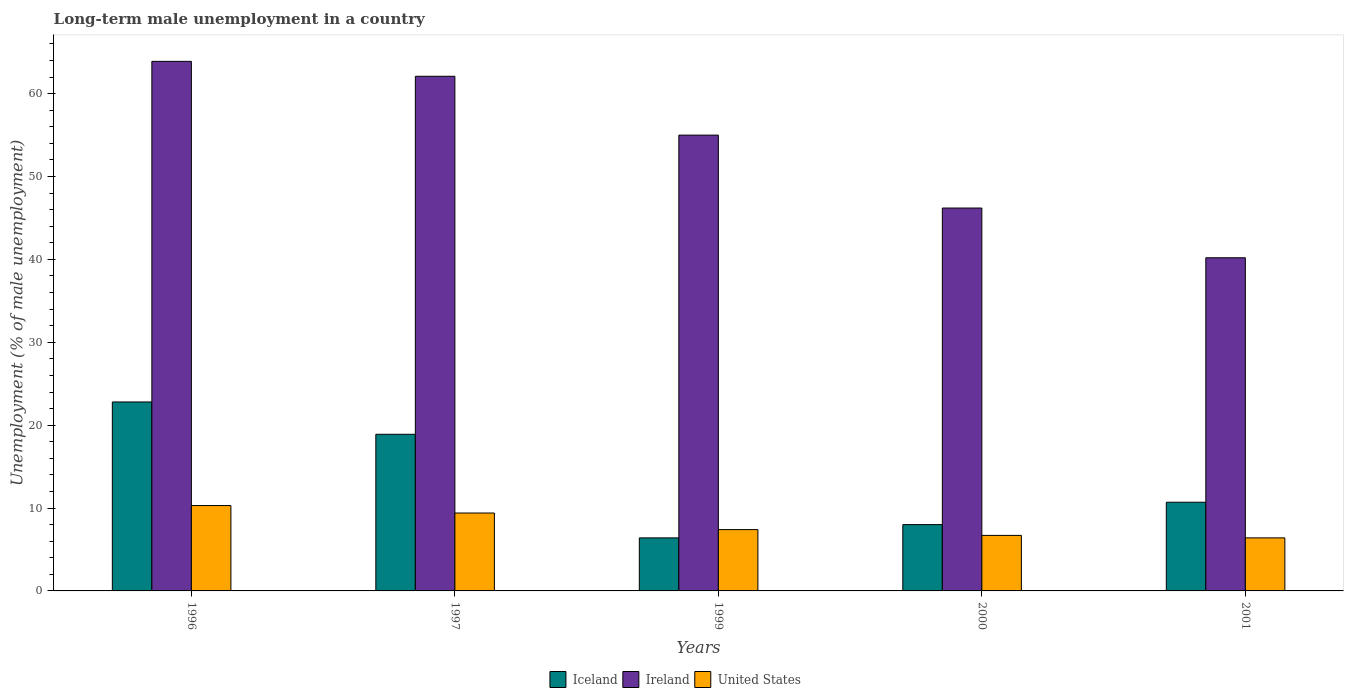Are the number of bars on each tick of the X-axis equal?
Your answer should be compact. Yes. How many bars are there on the 3rd tick from the left?
Provide a succinct answer. 3. How many bars are there on the 3rd tick from the right?
Your response must be concise. 3. What is the label of the 5th group of bars from the left?
Offer a terse response. 2001. What is the percentage of long-term unemployed male population in Ireland in 1997?
Provide a succinct answer. 62.1. Across all years, what is the maximum percentage of long-term unemployed male population in United States?
Provide a short and direct response. 10.3. Across all years, what is the minimum percentage of long-term unemployed male population in United States?
Make the answer very short. 6.4. What is the total percentage of long-term unemployed male population in Iceland in the graph?
Keep it short and to the point. 66.8. What is the difference between the percentage of long-term unemployed male population in United States in 1996 and that in 2001?
Offer a very short reply. 3.9. What is the difference between the percentage of long-term unemployed male population in Iceland in 2001 and the percentage of long-term unemployed male population in United States in 1996?
Provide a short and direct response. 0.4. What is the average percentage of long-term unemployed male population in Iceland per year?
Provide a succinct answer. 13.36. In the year 1996, what is the difference between the percentage of long-term unemployed male population in Ireland and percentage of long-term unemployed male population in Iceland?
Give a very brief answer. 41.1. In how many years, is the percentage of long-term unemployed male population in United States greater than 2 %?
Your answer should be very brief. 5. What is the ratio of the percentage of long-term unemployed male population in Ireland in 1997 to that in 1999?
Offer a terse response. 1.13. Is the difference between the percentage of long-term unemployed male population in Ireland in 1996 and 1999 greater than the difference between the percentage of long-term unemployed male population in Iceland in 1996 and 1999?
Your answer should be compact. No. What is the difference between the highest and the second highest percentage of long-term unemployed male population in United States?
Provide a short and direct response. 0.9. What is the difference between the highest and the lowest percentage of long-term unemployed male population in Iceland?
Your answer should be compact. 16.4. In how many years, is the percentage of long-term unemployed male population in Ireland greater than the average percentage of long-term unemployed male population in Ireland taken over all years?
Your answer should be compact. 3. What does the 1st bar from the left in 1999 represents?
Offer a very short reply. Iceland. What does the 3rd bar from the right in 1997 represents?
Give a very brief answer. Iceland. Is it the case that in every year, the sum of the percentage of long-term unemployed male population in United States and percentage of long-term unemployed male population in Ireland is greater than the percentage of long-term unemployed male population in Iceland?
Your answer should be compact. Yes. Are all the bars in the graph horizontal?
Offer a terse response. No. How many years are there in the graph?
Keep it short and to the point. 5. Does the graph contain any zero values?
Ensure brevity in your answer.  No. Does the graph contain grids?
Provide a succinct answer. No. Where does the legend appear in the graph?
Keep it short and to the point. Bottom center. What is the title of the graph?
Provide a succinct answer. Long-term male unemployment in a country. What is the label or title of the Y-axis?
Your answer should be compact. Unemployment (% of male unemployment). What is the Unemployment (% of male unemployment) in Iceland in 1996?
Offer a very short reply. 22.8. What is the Unemployment (% of male unemployment) of Ireland in 1996?
Your answer should be compact. 63.9. What is the Unemployment (% of male unemployment) of United States in 1996?
Ensure brevity in your answer.  10.3. What is the Unemployment (% of male unemployment) in Iceland in 1997?
Your answer should be very brief. 18.9. What is the Unemployment (% of male unemployment) of Ireland in 1997?
Give a very brief answer. 62.1. What is the Unemployment (% of male unemployment) in United States in 1997?
Offer a terse response. 9.4. What is the Unemployment (% of male unemployment) in Iceland in 1999?
Offer a very short reply. 6.4. What is the Unemployment (% of male unemployment) of Ireland in 1999?
Ensure brevity in your answer.  55. What is the Unemployment (% of male unemployment) in United States in 1999?
Your response must be concise. 7.4. What is the Unemployment (% of male unemployment) in Ireland in 2000?
Offer a terse response. 46.2. What is the Unemployment (% of male unemployment) in United States in 2000?
Give a very brief answer. 6.7. What is the Unemployment (% of male unemployment) of Iceland in 2001?
Provide a short and direct response. 10.7. What is the Unemployment (% of male unemployment) in Ireland in 2001?
Ensure brevity in your answer.  40.2. What is the Unemployment (% of male unemployment) of United States in 2001?
Provide a short and direct response. 6.4. Across all years, what is the maximum Unemployment (% of male unemployment) of Iceland?
Provide a short and direct response. 22.8. Across all years, what is the maximum Unemployment (% of male unemployment) in Ireland?
Your answer should be compact. 63.9. Across all years, what is the maximum Unemployment (% of male unemployment) of United States?
Your answer should be very brief. 10.3. Across all years, what is the minimum Unemployment (% of male unemployment) in Iceland?
Offer a terse response. 6.4. Across all years, what is the minimum Unemployment (% of male unemployment) in Ireland?
Your answer should be compact. 40.2. Across all years, what is the minimum Unemployment (% of male unemployment) in United States?
Give a very brief answer. 6.4. What is the total Unemployment (% of male unemployment) in Iceland in the graph?
Your answer should be compact. 66.8. What is the total Unemployment (% of male unemployment) of Ireland in the graph?
Offer a terse response. 267.4. What is the total Unemployment (% of male unemployment) in United States in the graph?
Ensure brevity in your answer.  40.2. What is the difference between the Unemployment (% of male unemployment) of United States in 1996 and that in 1997?
Provide a succinct answer. 0.9. What is the difference between the Unemployment (% of male unemployment) of United States in 1996 and that in 1999?
Offer a very short reply. 2.9. What is the difference between the Unemployment (% of male unemployment) in Iceland in 1996 and that in 2000?
Ensure brevity in your answer.  14.8. What is the difference between the Unemployment (% of male unemployment) of Ireland in 1996 and that in 2001?
Offer a terse response. 23.7. What is the difference between the Unemployment (% of male unemployment) of Iceland in 1997 and that in 1999?
Ensure brevity in your answer.  12.5. What is the difference between the Unemployment (% of male unemployment) in Ireland in 1997 and that in 1999?
Offer a terse response. 7.1. What is the difference between the Unemployment (% of male unemployment) of Ireland in 1997 and that in 2001?
Offer a terse response. 21.9. What is the difference between the Unemployment (% of male unemployment) in United States in 1997 and that in 2001?
Your answer should be very brief. 3. What is the difference between the Unemployment (% of male unemployment) of Iceland in 1999 and that in 2000?
Give a very brief answer. -1.6. What is the difference between the Unemployment (% of male unemployment) of Ireland in 1999 and that in 2000?
Offer a terse response. 8.8. What is the difference between the Unemployment (% of male unemployment) in United States in 1999 and that in 2000?
Provide a succinct answer. 0.7. What is the difference between the Unemployment (% of male unemployment) of Iceland in 1999 and that in 2001?
Keep it short and to the point. -4.3. What is the difference between the Unemployment (% of male unemployment) in Ireland in 1999 and that in 2001?
Ensure brevity in your answer.  14.8. What is the difference between the Unemployment (% of male unemployment) in United States in 1999 and that in 2001?
Give a very brief answer. 1. What is the difference between the Unemployment (% of male unemployment) of United States in 2000 and that in 2001?
Provide a short and direct response. 0.3. What is the difference between the Unemployment (% of male unemployment) of Iceland in 1996 and the Unemployment (% of male unemployment) of Ireland in 1997?
Your answer should be compact. -39.3. What is the difference between the Unemployment (% of male unemployment) in Ireland in 1996 and the Unemployment (% of male unemployment) in United States in 1997?
Your response must be concise. 54.5. What is the difference between the Unemployment (% of male unemployment) of Iceland in 1996 and the Unemployment (% of male unemployment) of Ireland in 1999?
Keep it short and to the point. -32.2. What is the difference between the Unemployment (% of male unemployment) of Iceland in 1996 and the Unemployment (% of male unemployment) of United States in 1999?
Offer a terse response. 15.4. What is the difference between the Unemployment (% of male unemployment) in Ireland in 1996 and the Unemployment (% of male unemployment) in United States in 1999?
Provide a short and direct response. 56.5. What is the difference between the Unemployment (% of male unemployment) of Iceland in 1996 and the Unemployment (% of male unemployment) of Ireland in 2000?
Your response must be concise. -23.4. What is the difference between the Unemployment (% of male unemployment) in Iceland in 1996 and the Unemployment (% of male unemployment) in United States in 2000?
Give a very brief answer. 16.1. What is the difference between the Unemployment (% of male unemployment) of Ireland in 1996 and the Unemployment (% of male unemployment) of United States in 2000?
Your answer should be compact. 57.2. What is the difference between the Unemployment (% of male unemployment) in Iceland in 1996 and the Unemployment (% of male unemployment) in Ireland in 2001?
Your response must be concise. -17.4. What is the difference between the Unemployment (% of male unemployment) of Ireland in 1996 and the Unemployment (% of male unemployment) of United States in 2001?
Offer a terse response. 57.5. What is the difference between the Unemployment (% of male unemployment) of Iceland in 1997 and the Unemployment (% of male unemployment) of Ireland in 1999?
Offer a very short reply. -36.1. What is the difference between the Unemployment (% of male unemployment) in Ireland in 1997 and the Unemployment (% of male unemployment) in United States in 1999?
Your answer should be compact. 54.7. What is the difference between the Unemployment (% of male unemployment) of Iceland in 1997 and the Unemployment (% of male unemployment) of Ireland in 2000?
Provide a short and direct response. -27.3. What is the difference between the Unemployment (% of male unemployment) of Ireland in 1997 and the Unemployment (% of male unemployment) of United States in 2000?
Your answer should be compact. 55.4. What is the difference between the Unemployment (% of male unemployment) in Iceland in 1997 and the Unemployment (% of male unemployment) in Ireland in 2001?
Offer a very short reply. -21.3. What is the difference between the Unemployment (% of male unemployment) in Iceland in 1997 and the Unemployment (% of male unemployment) in United States in 2001?
Offer a very short reply. 12.5. What is the difference between the Unemployment (% of male unemployment) of Ireland in 1997 and the Unemployment (% of male unemployment) of United States in 2001?
Offer a terse response. 55.7. What is the difference between the Unemployment (% of male unemployment) in Iceland in 1999 and the Unemployment (% of male unemployment) in Ireland in 2000?
Your answer should be compact. -39.8. What is the difference between the Unemployment (% of male unemployment) in Iceland in 1999 and the Unemployment (% of male unemployment) in United States in 2000?
Offer a terse response. -0.3. What is the difference between the Unemployment (% of male unemployment) in Ireland in 1999 and the Unemployment (% of male unemployment) in United States in 2000?
Make the answer very short. 48.3. What is the difference between the Unemployment (% of male unemployment) of Iceland in 1999 and the Unemployment (% of male unemployment) of Ireland in 2001?
Your answer should be compact. -33.8. What is the difference between the Unemployment (% of male unemployment) in Iceland in 1999 and the Unemployment (% of male unemployment) in United States in 2001?
Provide a succinct answer. 0. What is the difference between the Unemployment (% of male unemployment) of Ireland in 1999 and the Unemployment (% of male unemployment) of United States in 2001?
Ensure brevity in your answer.  48.6. What is the difference between the Unemployment (% of male unemployment) of Iceland in 2000 and the Unemployment (% of male unemployment) of Ireland in 2001?
Your response must be concise. -32.2. What is the difference between the Unemployment (% of male unemployment) in Iceland in 2000 and the Unemployment (% of male unemployment) in United States in 2001?
Your answer should be compact. 1.6. What is the difference between the Unemployment (% of male unemployment) of Ireland in 2000 and the Unemployment (% of male unemployment) of United States in 2001?
Give a very brief answer. 39.8. What is the average Unemployment (% of male unemployment) in Iceland per year?
Offer a terse response. 13.36. What is the average Unemployment (% of male unemployment) of Ireland per year?
Ensure brevity in your answer.  53.48. What is the average Unemployment (% of male unemployment) in United States per year?
Your response must be concise. 8.04. In the year 1996, what is the difference between the Unemployment (% of male unemployment) in Iceland and Unemployment (% of male unemployment) in Ireland?
Offer a very short reply. -41.1. In the year 1996, what is the difference between the Unemployment (% of male unemployment) in Iceland and Unemployment (% of male unemployment) in United States?
Ensure brevity in your answer.  12.5. In the year 1996, what is the difference between the Unemployment (% of male unemployment) in Ireland and Unemployment (% of male unemployment) in United States?
Your response must be concise. 53.6. In the year 1997, what is the difference between the Unemployment (% of male unemployment) in Iceland and Unemployment (% of male unemployment) in Ireland?
Offer a very short reply. -43.2. In the year 1997, what is the difference between the Unemployment (% of male unemployment) in Iceland and Unemployment (% of male unemployment) in United States?
Your response must be concise. 9.5. In the year 1997, what is the difference between the Unemployment (% of male unemployment) in Ireland and Unemployment (% of male unemployment) in United States?
Make the answer very short. 52.7. In the year 1999, what is the difference between the Unemployment (% of male unemployment) in Iceland and Unemployment (% of male unemployment) in Ireland?
Provide a succinct answer. -48.6. In the year 1999, what is the difference between the Unemployment (% of male unemployment) in Ireland and Unemployment (% of male unemployment) in United States?
Provide a short and direct response. 47.6. In the year 2000, what is the difference between the Unemployment (% of male unemployment) in Iceland and Unemployment (% of male unemployment) in Ireland?
Offer a terse response. -38.2. In the year 2000, what is the difference between the Unemployment (% of male unemployment) of Ireland and Unemployment (% of male unemployment) of United States?
Offer a terse response. 39.5. In the year 2001, what is the difference between the Unemployment (% of male unemployment) of Iceland and Unemployment (% of male unemployment) of Ireland?
Make the answer very short. -29.5. In the year 2001, what is the difference between the Unemployment (% of male unemployment) of Iceland and Unemployment (% of male unemployment) of United States?
Make the answer very short. 4.3. In the year 2001, what is the difference between the Unemployment (% of male unemployment) of Ireland and Unemployment (% of male unemployment) of United States?
Provide a short and direct response. 33.8. What is the ratio of the Unemployment (% of male unemployment) of Iceland in 1996 to that in 1997?
Provide a short and direct response. 1.21. What is the ratio of the Unemployment (% of male unemployment) of United States in 1996 to that in 1997?
Your response must be concise. 1.1. What is the ratio of the Unemployment (% of male unemployment) in Iceland in 1996 to that in 1999?
Ensure brevity in your answer.  3.56. What is the ratio of the Unemployment (% of male unemployment) in Ireland in 1996 to that in 1999?
Make the answer very short. 1.16. What is the ratio of the Unemployment (% of male unemployment) of United States in 1996 to that in 1999?
Your response must be concise. 1.39. What is the ratio of the Unemployment (% of male unemployment) in Iceland in 1996 to that in 2000?
Your response must be concise. 2.85. What is the ratio of the Unemployment (% of male unemployment) of Ireland in 1996 to that in 2000?
Provide a succinct answer. 1.38. What is the ratio of the Unemployment (% of male unemployment) of United States in 1996 to that in 2000?
Ensure brevity in your answer.  1.54. What is the ratio of the Unemployment (% of male unemployment) of Iceland in 1996 to that in 2001?
Offer a terse response. 2.13. What is the ratio of the Unemployment (% of male unemployment) in Ireland in 1996 to that in 2001?
Give a very brief answer. 1.59. What is the ratio of the Unemployment (% of male unemployment) in United States in 1996 to that in 2001?
Give a very brief answer. 1.61. What is the ratio of the Unemployment (% of male unemployment) of Iceland in 1997 to that in 1999?
Your answer should be compact. 2.95. What is the ratio of the Unemployment (% of male unemployment) in Ireland in 1997 to that in 1999?
Your response must be concise. 1.13. What is the ratio of the Unemployment (% of male unemployment) of United States in 1997 to that in 1999?
Give a very brief answer. 1.27. What is the ratio of the Unemployment (% of male unemployment) in Iceland in 1997 to that in 2000?
Provide a succinct answer. 2.36. What is the ratio of the Unemployment (% of male unemployment) of Ireland in 1997 to that in 2000?
Ensure brevity in your answer.  1.34. What is the ratio of the Unemployment (% of male unemployment) of United States in 1997 to that in 2000?
Keep it short and to the point. 1.4. What is the ratio of the Unemployment (% of male unemployment) in Iceland in 1997 to that in 2001?
Offer a very short reply. 1.77. What is the ratio of the Unemployment (% of male unemployment) of Ireland in 1997 to that in 2001?
Ensure brevity in your answer.  1.54. What is the ratio of the Unemployment (% of male unemployment) of United States in 1997 to that in 2001?
Ensure brevity in your answer.  1.47. What is the ratio of the Unemployment (% of male unemployment) in Ireland in 1999 to that in 2000?
Make the answer very short. 1.19. What is the ratio of the Unemployment (% of male unemployment) in United States in 1999 to that in 2000?
Offer a very short reply. 1.1. What is the ratio of the Unemployment (% of male unemployment) in Iceland in 1999 to that in 2001?
Your answer should be compact. 0.6. What is the ratio of the Unemployment (% of male unemployment) in Ireland in 1999 to that in 2001?
Give a very brief answer. 1.37. What is the ratio of the Unemployment (% of male unemployment) of United States in 1999 to that in 2001?
Keep it short and to the point. 1.16. What is the ratio of the Unemployment (% of male unemployment) of Iceland in 2000 to that in 2001?
Offer a terse response. 0.75. What is the ratio of the Unemployment (% of male unemployment) of Ireland in 2000 to that in 2001?
Give a very brief answer. 1.15. What is the ratio of the Unemployment (% of male unemployment) of United States in 2000 to that in 2001?
Make the answer very short. 1.05. What is the difference between the highest and the second highest Unemployment (% of male unemployment) of Iceland?
Ensure brevity in your answer.  3.9. What is the difference between the highest and the second highest Unemployment (% of male unemployment) of Ireland?
Ensure brevity in your answer.  1.8. What is the difference between the highest and the second highest Unemployment (% of male unemployment) in United States?
Keep it short and to the point. 0.9. What is the difference between the highest and the lowest Unemployment (% of male unemployment) of Iceland?
Your answer should be compact. 16.4. What is the difference between the highest and the lowest Unemployment (% of male unemployment) in Ireland?
Ensure brevity in your answer.  23.7. What is the difference between the highest and the lowest Unemployment (% of male unemployment) of United States?
Keep it short and to the point. 3.9. 